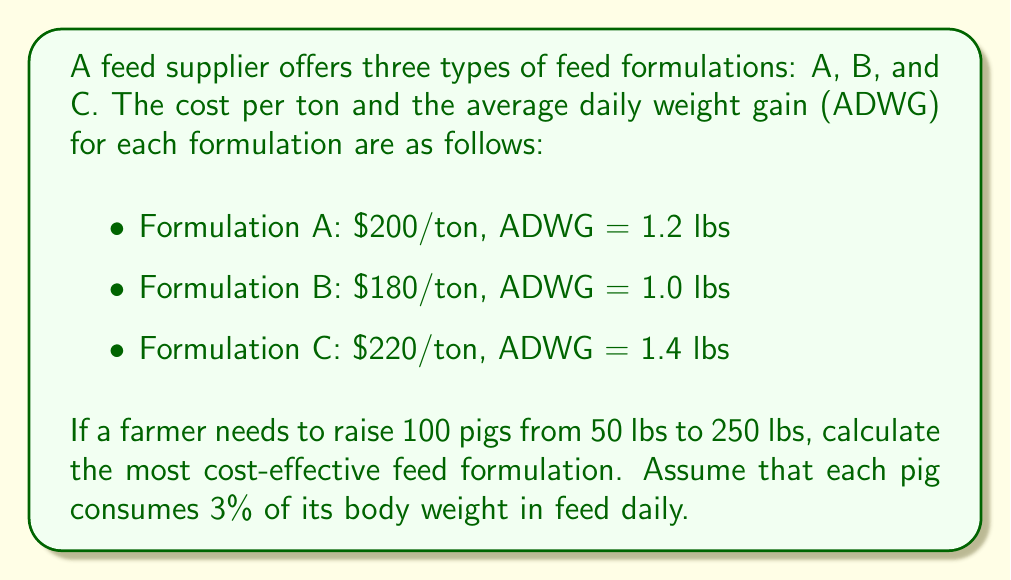Give your solution to this math problem. To determine the most cost-effective feed formulation, we need to calculate the total cost for each formulation to raise 100 pigs from 50 lbs to 250 lbs.

Step 1: Calculate the number of days required for each formulation.
Days required = (Target weight - Initial weight) ÷ ADWG
- Formulation A: $$(250 - 50) \div 1.2 = 166.67$$ days
- Formulation B: $$(250 - 50) \div 1.0 = 200$$ days
- Formulation C: $$(250 - 50) \div 1.4 = 142.86$$ days

Step 2: Calculate the average weight of a pig during the feeding period.
Average weight = (Initial weight + Target weight) ÷ 2
$$\text{Average weight} = (50 + 250) \div 2 = 150$$ lbs

Step 3: Calculate the daily feed consumption per pig.
Daily feed consumption = 3% of average weight
$$\text{Daily feed consumption} = 150 \times 0.03 = 4.5$$ lbs

Step 4: Calculate the total feed consumed per pig for each formulation.
Total feed consumed = Daily feed consumption × Days required
- Formulation A: $$4.5 \times 166.67 = 750$$ lbs
- Formulation B: $$4.5 \times 200 = 900$$ lbs
- Formulation C: $$4.5 \times 142.86 = 642.87$$ lbs

Step 5: Calculate the total feed consumed for 100 pigs.
- Formulation A: $$750 \times 100 = 75,000$$ lbs = 37.5 tons
- Formulation B: $$900 \times 100 = 90,000$$ lbs = 45 tons
- Formulation C: $$642.87 \times 100 = 64,287$$ lbs = 32.1435 tons

Step 6: Calculate the total cost for each formulation.
- Formulation A: $$37.5 \times $200 = $7,500$$
- Formulation B: $$45 \times $180 = $8,100$$
- Formulation C: $$32.1435 \times $220 = $7,071.57$$

Therefore, Formulation C is the most cost-effective, with a total cost of $7,071.57 for raising 100 pigs from 50 lbs to 250 lbs.
Answer: Formulation C ($7,071.57) 